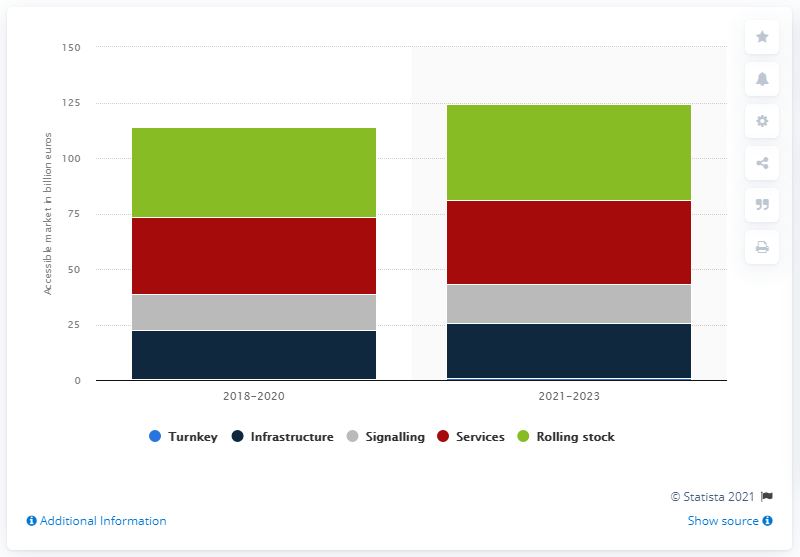Specify some key components in this picture. The estimated value of the services market is projected to be around 37.7 billion dollars between 2021 and 2023. The average annual value of rolling stock in the world between 2021 and 2023 is estimated to be approximately 43.4 billion dollars. 